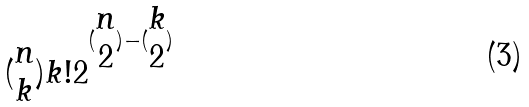Convert formula to latex. <formula><loc_0><loc_0><loc_500><loc_500>( \begin{matrix} n \\ k \end{matrix} ) k ! 2 ^ { ( \begin{matrix} n \\ 2 \end{matrix} ) - ( \begin{matrix} k \\ 2 \end{matrix} ) }</formula> 